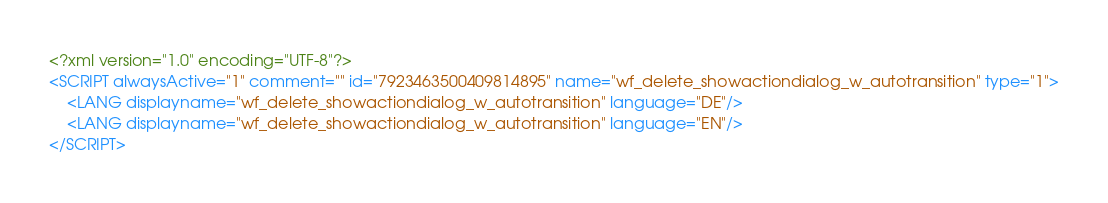<code> <loc_0><loc_0><loc_500><loc_500><_XML_><?xml version="1.0" encoding="UTF-8"?>
<SCRIPT alwaysActive="1" comment="" id="7923463500409814895" name="wf_delete_showactiondialog_w_autotransition" type="1">
	<LANG displayname="wf_delete_showactiondialog_w_autotransition" language="DE"/>
	<LANG displayname="wf_delete_showactiondialog_w_autotransition" language="EN"/>
</SCRIPT>
</code> 